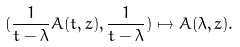<formula> <loc_0><loc_0><loc_500><loc_500>( \frac { 1 } { t - \lambda } A ( t , z ) , \frac { 1 } { t - \lambda } ) \mapsto A ( \lambda , z ) .</formula> 